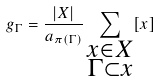<formula> <loc_0><loc_0><loc_500><loc_500>g _ { \Gamma } = \frac { | X | } { a _ { \pi ( \Gamma ) } } \sum _ { \substack { x \in X \\ \Gamma \subset x } } [ x ]</formula> 